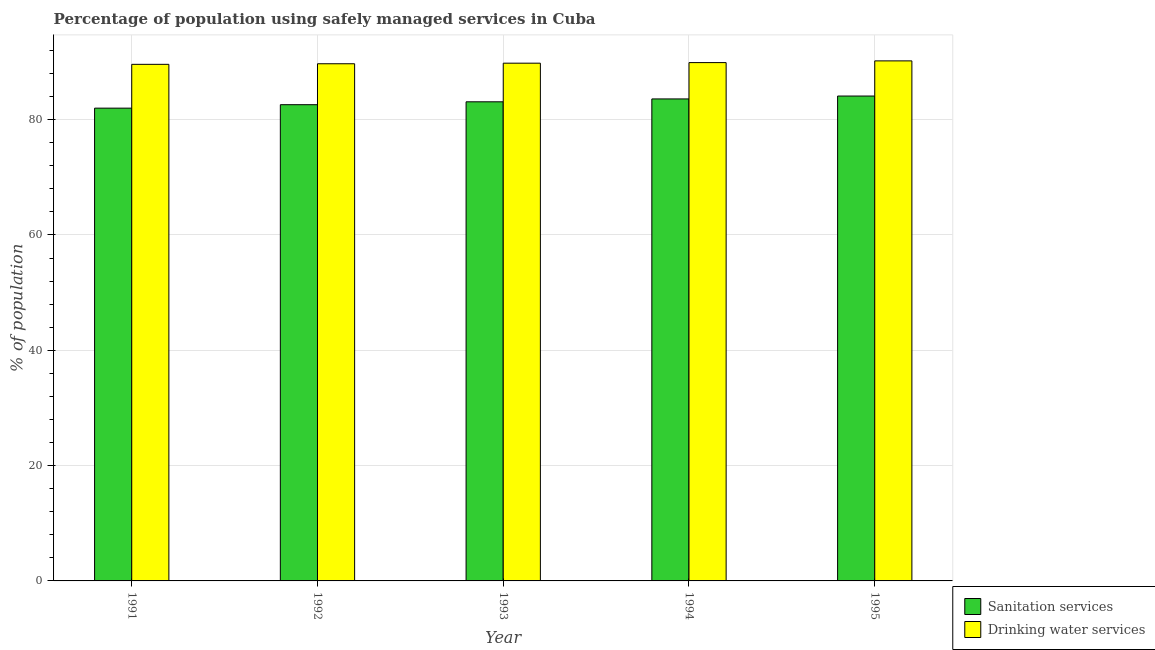How many groups of bars are there?
Your answer should be compact. 5. Are the number of bars per tick equal to the number of legend labels?
Give a very brief answer. Yes. How many bars are there on the 3rd tick from the right?
Offer a very short reply. 2. What is the label of the 5th group of bars from the left?
Make the answer very short. 1995. In how many cases, is the number of bars for a given year not equal to the number of legend labels?
Your answer should be compact. 0. What is the percentage of population who used sanitation services in 1992?
Ensure brevity in your answer.  82.6. Across all years, what is the maximum percentage of population who used drinking water services?
Offer a terse response. 90.2. In which year was the percentage of population who used sanitation services minimum?
Provide a succinct answer. 1991. What is the total percentage of population who used drinking water services in the graph?
Your answer should be very brief. 449.2. What is the difference between the percentage of population who used sanitation services in 1991 and that in 1994?
Ensure brevity in your answer.  -1.6. What is the difference between the percentage of population who used drinking water services in 1993 and the percentage of population who used sanitation services in 1995?
Make the answer very short. -0.4. What is the average percentage of population who used sanitation services per year?
Your answer should be very brief. 83.08. In how many years, is the percentage of population who used drinking water services greater than 36 %?
Make the answer very short. 5. What is the ratio of the percentage of population who used sanitation services in 1991 to that in 1994?
Your answer should be compact. 0.98. Is the difference between the percentage of population who used sanitation services in 1992 and 1994 greater than the difference between the percentage of population who used drinking water services in 1992 and 1994?
Provide a succinct answer. No. What is the difference between the highest and the second highest percentage of population who used drinking water services?
Give a very brief answer. 0.3. What is the difference between the highest and the lowest percentage of population who used sanitation services?
Your response must be concise. 2.1. Is the sum of the percentage of population who used drinking water services in 1992 and 1993 greater than the maximum percentage of population who used sanitation services across all years?
Make the answer very short. Yes. What does the 2nd bar from the left in 1994 represents?
Your answer should be very brief. Drinking water services. What does the 1st bar from the right in 1995 represents?
Offer a terse response. Drinking water services. Are all the bars in the graph horizontal?
Your answer should be compact. No. How many years are there in the graph?
Keep it short and to the point. 5. Are the values on the major ticks of Y-axis written in scientific E-notation?
Provide a succinct answer. No. Does the graph contain any zero values?
Give a very brief answer. No. Where does the legend appear in the graph?
Your response must be concise. Bottom right. How many legend labels are there?
Make the answer very short. 2. How are the legend labels stacked?
Ensure brevity in your answer.  Vertical. What is the title of the graph?
Offer a very short reply. Percentage of population using safely managed services in Cuba. What is the label or title of the Y-axis?
Offer a very short reply. % of population. What is the % of population of Drinking water services in 1991?
Offer a very short reply. 89.6. What is the % of population in Sanitation services in 1992?
Keep it short and to the point. 82.6. What is the % of population of Drinking water services in 1992?
Ensure brevity in your answer.  89.7. What is the % of population of Sanitation services in 1993?
Provide a succinct answer. 83.1. What is the % of population in Drinking water services in 1993?
Offer a very short reply. 89.8. What is the % of population in Sanitation services in 1994?
Your answer should be compact. 83.6. What is the % of population of Drinking water services in 1994?
Your answer should be very brief. 89.9. What is the % of population in Sanitation services in 1995?
Your answer should be compact. 84.1. What is the % of population in Drinking water services in 1995?
Give a very brief answer. 90.2. Across all years, what is the maximum % of population of Sanitation services?
Keep it short and to the point. 84.1. Across all years, what is the maximum % of population of Drinking water services?
Provide a short and direct response. 90.2. Across all years, what is the minimum % of population in Sanitation services?
Provide a short and direct response. 82. Across all years, what is the minimum % of population in Drinking water services?
Your answer should be very brief. 89.6. What is the total % of population in Sanitation services in the graph?
Keep it short and to the point. 415.4. What is the total % of population in Drinking water services in the graph?
Make the answer very short. 449.2. What is the difference between the % of population of Sanitation services in 1991 and that in 1993?
Provide a succinct answer. -1.1. What is the difference between the % of population of Sanitation services in 1991 and that in 1994?
Your answer should be compact. -1.6. What is the difference between the % of population of Drinking water services in 1991 and that in 1994?
Provide a succinct answer. -0.3. What is the difference between the % of population of Sanitation services in 1991 and that in 1995?
Make the answer very short. -2.1. What is the difference between the % of population of Drinking water services in 1991 and that in 1995?
Your answer should be compact. -0.6. What is the difference between the % of population of Drinking water services in 1992 and that in 1994?
Offer a terse response. -0.2. What is the difference between the % of population of Drinking water services in 1992 and that in 1995?
Ensure brevity in your answer.  -0.5. What is the difference between the % of population in Sanitation services in 1993 and that in 1994?
Make the answer very short. -0.5. What is the difference between the % of population in Sanitation services in 1993 and that in 1995?
Keep it short and to the point. -1. What is the difference between the % of population of Drinking water services in 1993 and that in 1995?
Give a very brief answer. -0.4. What is the difference between the % of population of Drinking water services in 1994 and that in 1995?
Offer a terse response. -0.3. What is the difference between the % of population of Sanitation services in 1991 and the % of population of Drinking water services in 1993?
Provide a short and direct response. -7.8. What is the difference between the % of population of Sanitation services in 1991 and the % of population of Drinking water services in 1995?
Offer a terse response. -8.2. What is the difference between the % of population in Sanitation services in 1992 and the % of population in Drinking water services in 1993?
Your answer should be compact. -7.2. What is the difference between the % of population of Sanitation services in 1992 and the % of population of Drinking water services in 1994?
Ensure brevity in your answer.  -7.3. What is the difference between the % of population of Sanitation services in 1992 and the % of population of Drinking water services in 1995?
Provide a succinct answer. -7.6. What is the difference between the % of population in Sanitation services in 1993 and the % of population in Drinking water services in 1995?
Give a very brief answer. -7.1. What is the difference between the % of population of Sanitation services in 1994 and the % of population of Drinking water services in 1995?
Offer a terse response. -6.6. What is the average % of population of Sanitation services per year?
Your answer should be compact. 83.08. What is the average % of population of Drinking water services per year?
Your answer should be very brief. 89.84. In the year 1993, what is the difference between the % of population in Sanitation services and % of population in Drinking water services?
Offer a terse response. -6.7. What is the ratio of the % of population in Sanitation services in 1991 to that in 1992?
Your answer should be compact. 0.99. What is the ratio of the % of population of Drinking water services in 1991 to that in 1992?
Provide a succinct answer. 1. What is the ratio of the % of population in Sanitation services in 1991 to that in 1993?
Offer a terse response. 0.99. What is the ratio of the % of population in Sanitation services in 1991 to that in 1994?
Your answer should be compact. 0.98. What is the ratio of the % of population of Drinking water services in 1991 to that in 1994?
Offer a very short reply. 1. What is the ratio of the % of population of Sanitation services in 1991 to that in 1995?
Give a very brief answer. 0.97. What is the ratio of the % of population in Drinking water services in 1991 to that in 1995?
Ensure brevity in your answer.  0.99. What is the ratio of the % of population in Sanitation services in 1992 to that in 1994?
Give a very brief answer. 0.99. What is the ratio of the % of population of Drinking water services in 1992 to that in 1994?
Offer a terse response. 1. What is the ratio of the % of population of Sanitation services in 1992 to that in 1995?
Your answer should be compact. 0.98. What is the ratio of the % of population in Drinking water services in 1992 to that in 1995?
Your response must be concise. 0.99. What is the ratio of the % of population in Sanitation services in 1993 to that in 1995?
Offer a terse response. 0.99. What is the ratio of the % of population in Sanitation services in 1994 to that in 1995?
Make the answer very short. 0.99. What is the difference between the highest and the lowest % of population in Sanitation services?
Give a very brief answer. 2.1. 